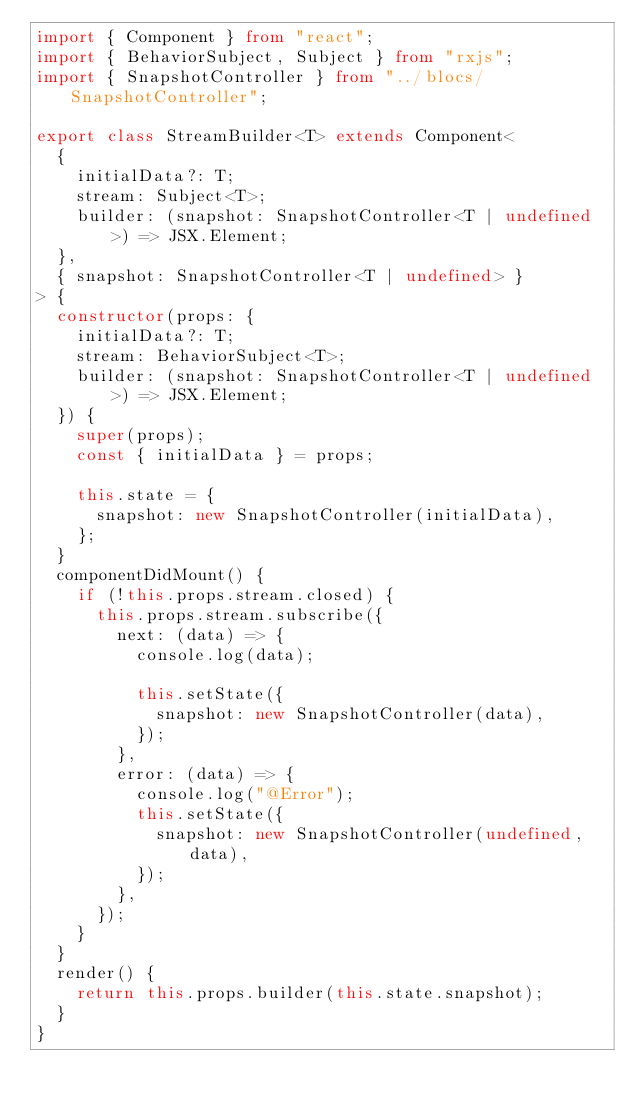Convert code to text. <code><loc_0><loc_0><loc_500><loc_500><_TypeScript_>import { Component } from "react";
import { BehaviorSubject, Subject } from "rxjs";
import { SnapshotController } from "../blocs/SnapshotController";

export class StreamBuilder<T> extends Component<
  {
    initialData?: T;
    stream: Subject<T>;
    builder: (snapshot: SnapshotController<T | undefined>) => JSX.Element;
  },
  { snapshot: SnapshotController<T | undefined> }
> {
  constructor(props: {
    initialData?: T;
    stream: BehaviorSubject<T>;
    builder: (snapshot: SnapshotController<T | undefined>) => JSX.Element;
  }) {
    super(props);
    const { initialData } = props;

    this.state = {
      snapshot: new SnapshotController(initialData),
    };
  }
  componentDidMount() {
    if (!this.props.stream.closed) {
      this.props.stream.subscribe({
        next: (data) => {
          console.log(data);

          this.setState({
            snapshot: new SnapshotController(data),
          });
        },
        error: (data) => {
          console.log("@Error");
          this.setState({
            snapshot: new SnapshotController(undefined, data),
          });
        },
      });
    }
  }
  render() {
    return this.props.builder(this.state.snapshot);
  }
}
</code> 